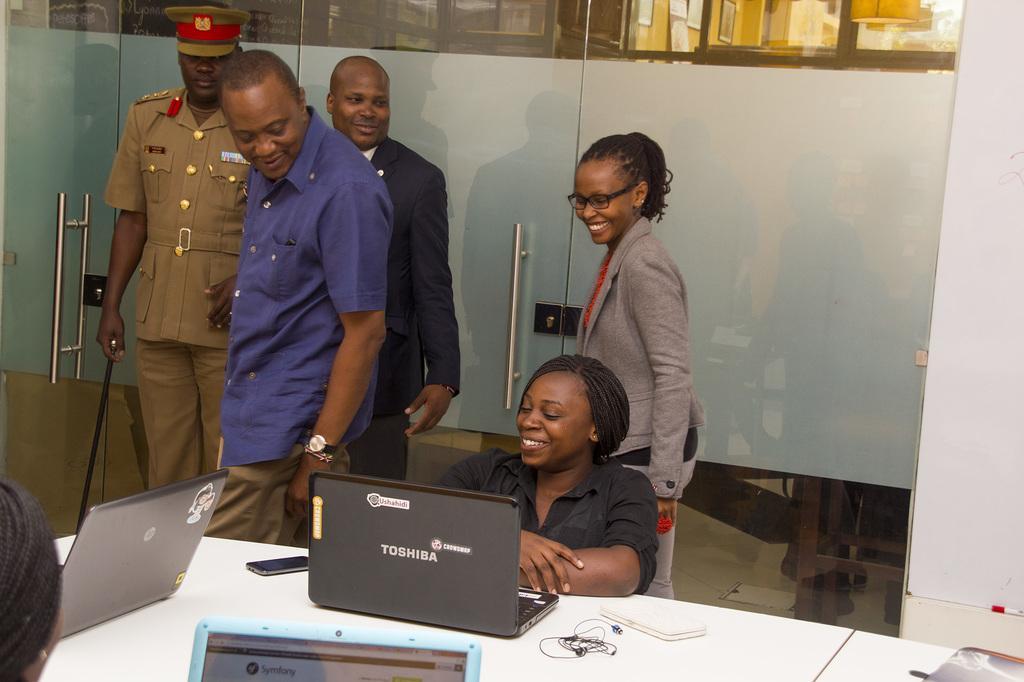Could you give a brief overview of what you see in this image? In this picture there is a man who is wearing blue shirt, watch and trouser. He is standing near to the table. On the table we can see the laptops, earphones, mobile phone, power bank, purse and other object. In the centre there is a woman who is wearing black dress. She is sitting on the chair, behind her we can see another woman who is wearing spectacle, blazer and red dress. She is standing near to the door, beside her there is a man who is wearing suit. Beside him we can see the officer who is holding a stick. On the right there is a boat. In the background we can see the room. 